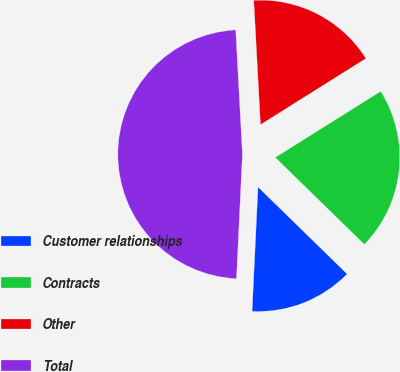Convert chart to OTSL. <chart><loc_0><loc_0><loc_500><loc_500><pie_chart><fcel>Customer relationships<fcel>Contracts<fcel>Other<fcel>Total<nl><fcel>13.45%<fcel>21.23%<fcel>16.94%<fcel>48.39%<nl></chart> 